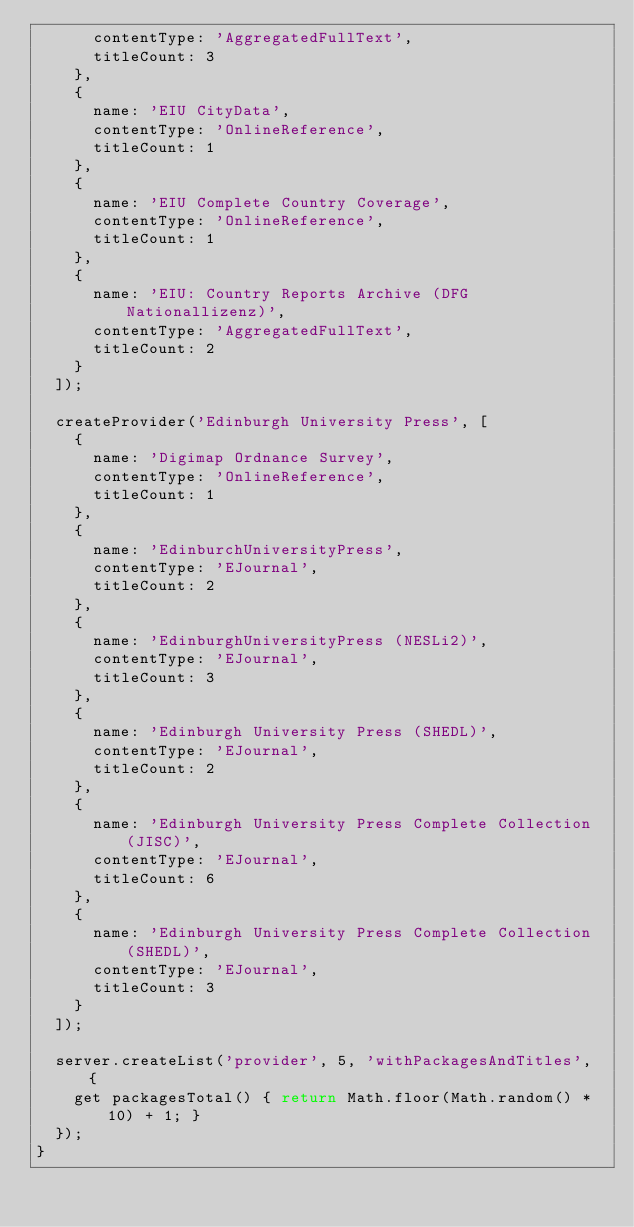<code> <loc_0><loc_0><loc_500><loc_500><_JavaScript_>      contentType: 'AggregatedFullText',
      titleCount: 3
    },
    {
      name: 'EIU CityData',
      contentType: 'OnlineReference',
      titleCount: 1
    },
    {
      name: 'EIU Complete Country Coverage',
      contentType: 'OnlineReference',
      titleCount: 1
    },
    {
      name: 'EIU: Country Reports Archive (DFG Nationallizenz)',
      contentType: 'AggregatedFullText',
      titleCount: 2
    }
  ]);

  createProvider('Edinburgh University Press', [
    {
      name: 'Digimap Ordnance Survey',
      contentType: 'OnlineReference',
      titleCount: 1
    },
    {
      name: 'EdinburchUniversityPress',
      contentType: 'EJournal',
      titleCount: 2
    },
    {
      name: 'EdinburghUniversityPress (NESLi2)',
      contentType: 'EJournal',
      titleCount: 3
    },
    {
      name: 'Edinburgh University Press (SHEDL)',
      contentType: 'EJournal',
      titleCount: 2
    },
    {
      name: 'Edinburgh University Press Complete Collection (JISC)',
      contentType: 'EJournal',
      titleCount: 6
    },
    {
      name: 'Edinburgh University Press Complete Collection (SHEDL)',
      contentType: 'EJournal',
      titleCount: 3
    }
  ]);

  server.createList('provider', 5, 'withPackagesAndTitles', {
    get packagesTotal() { return Math.floor(Math.random() * 10) + 1; }
  });
}
</code> 